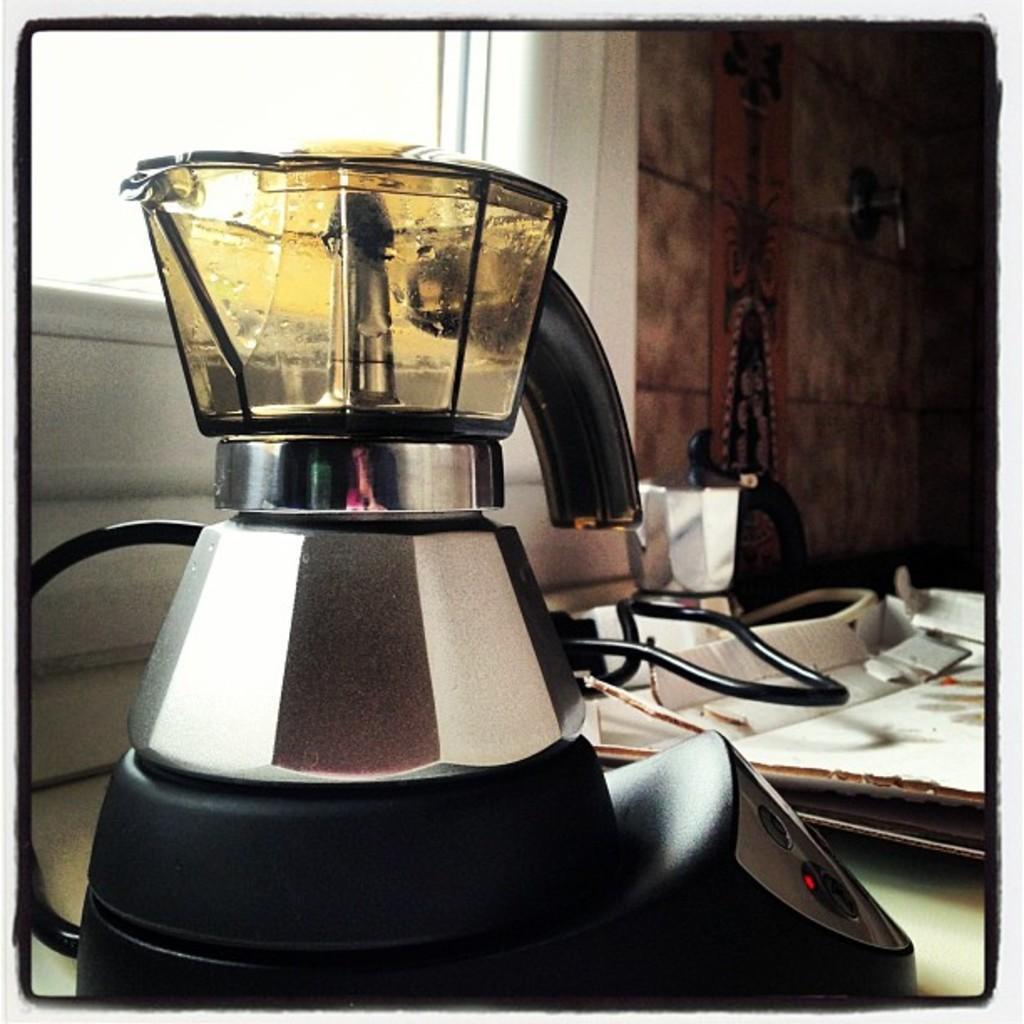How would you summarize this image in a sentence or two? In the image there is a mixer and there is a jar kept on the machine,behind machine there is a window and beside the window there is a wall. 